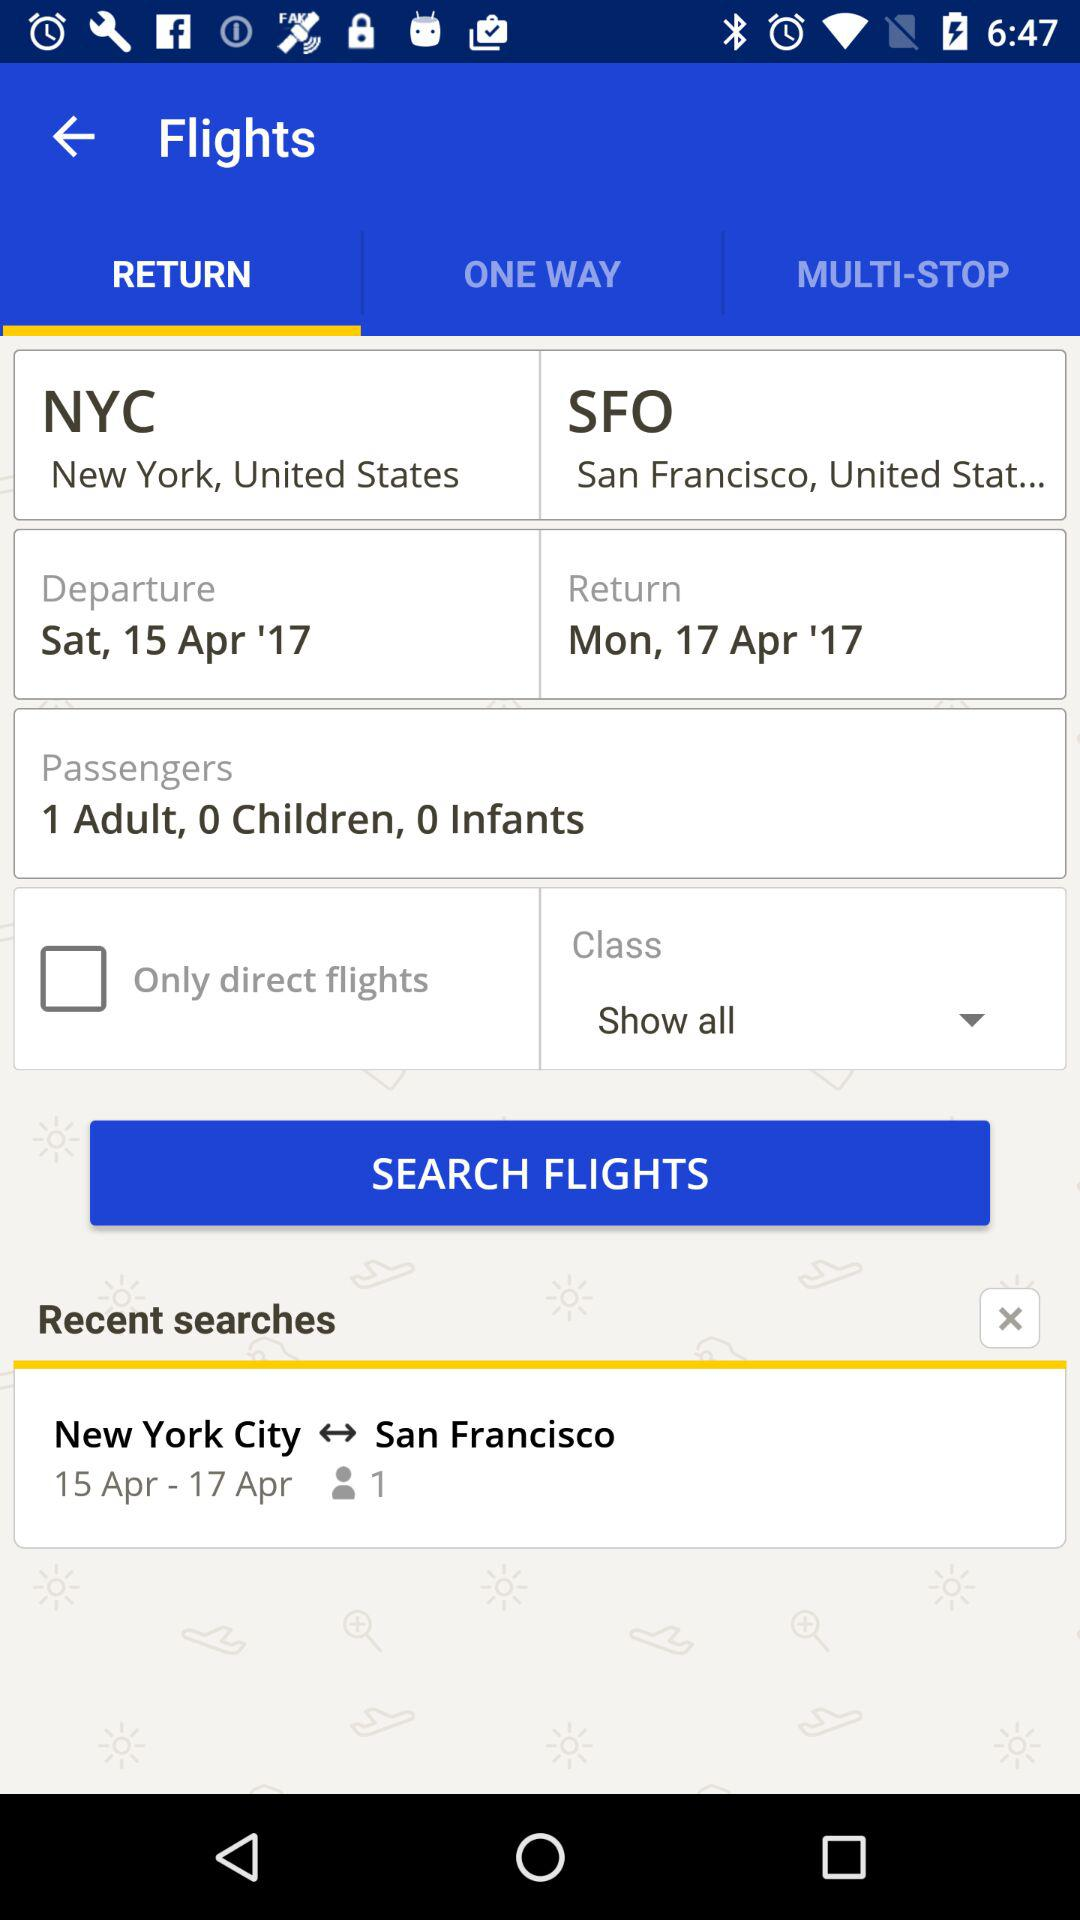How many days are between the departure and return dates?
Answer the question using a single word or phrase. 2 